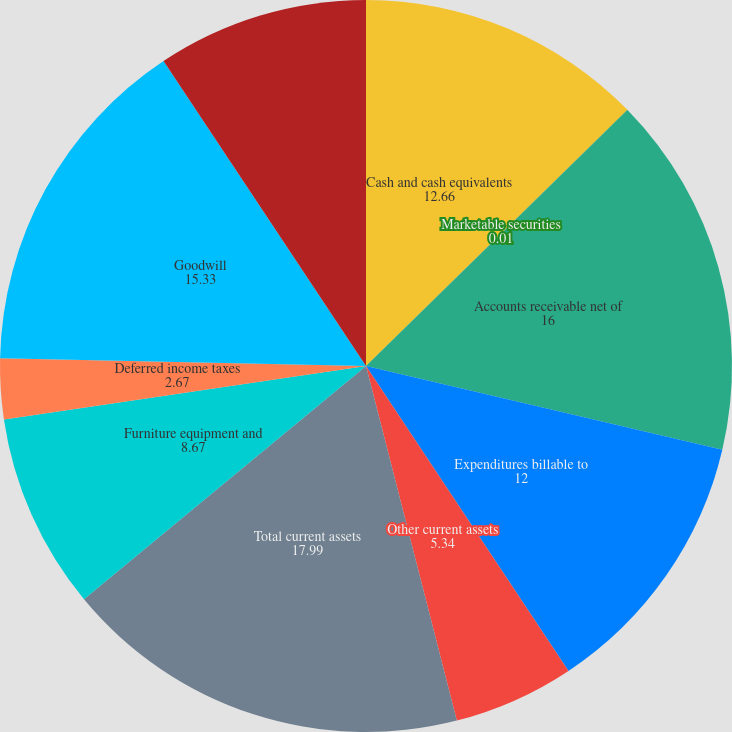<chart> <loc_0><loc_0><loc_500><loc_500><pie_chart><fcel>Cash and cash equivalents<fcel>Marketable securities<fcel>Accounts receivable net of<fcel>Expenditures billable to<fcel>Other current assets<fcel>Total current assets<fcel>Furniture equipment and<fcel>Deferred income taxes<fcel>Goodwill<fcel>Other non-current assets<nl><fcel>12.66%<fcel>0.01%<fcel>16.0%<fcel>12.0%<fcel>5.34%<fcel>17.99%<fcel>8.67%<fcel>2.67%<fcel>15.33%<fcel>9.33%<nl></chart> 